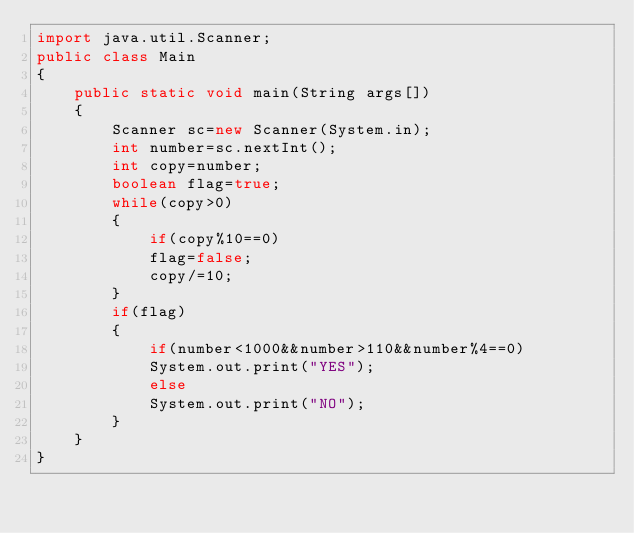<code> <loc_0><loc_0><loc_500><loc_500><_Java_>import java.util.Scanner;
public class Main
{
    public static void main(String args[])
    {
        Scanner sc=new Scanner(System.in);
        int number=sc.nextInt();
        int copy=number;
        boolean flag=true;
        while(copy>0)
        {
            if(copy%10==0)
            flag=false;
            copy/=10;
        }
        if(flag)
        {
            if(number<1000&&number>110&&number%4==0)
            System.out.print("YES");
            else
            System.out.print("NO");
        }
    }
}</code> 